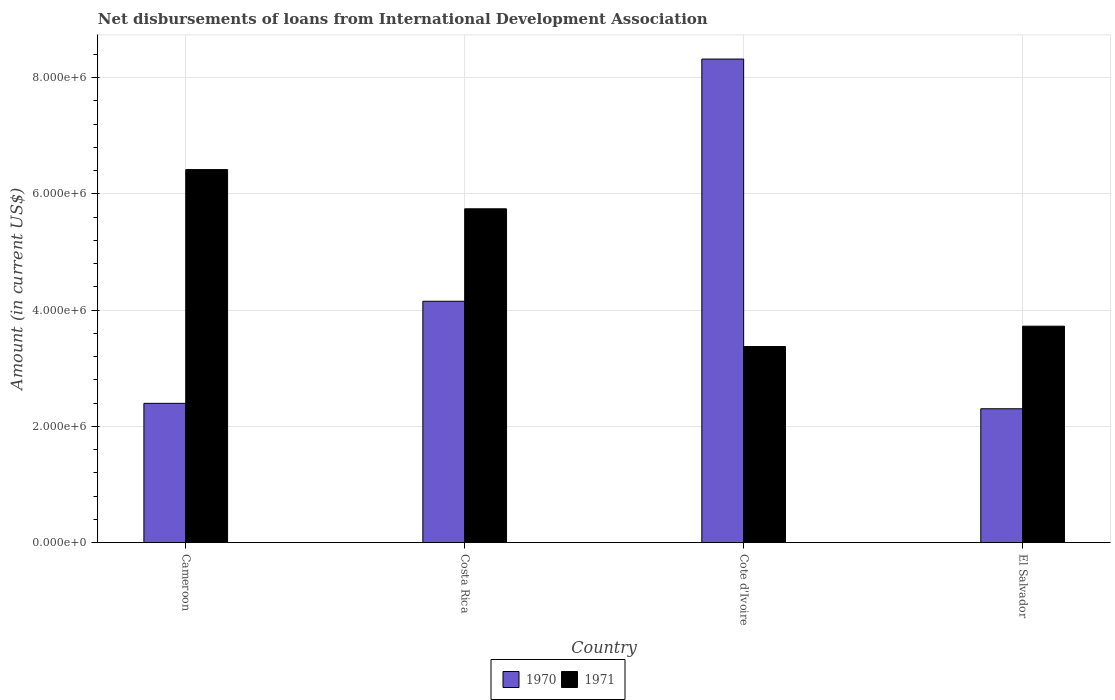How many different coloured bars are there?
Give a very brief answer. 2. How many groups of bars are there?
Keep it short and to the point. 4. How many bars are there on the 3rd tick from the left?
Offer a terse response. 2. What is the label of the 3rd group of bars from the left?
Make the answer very short. Cote d'Ivoire. In how many cases, is the number of bars for a given country not equal to the number of legend labels?
Give a very brief answer. 0. What is the amount of loans disbursed in 1970 in El Salvador?
Offer a very short reply. 2.30e+06. Across all countries, what is the maximum amount of loans disbursed in 1970?
Offer a terse response. 8.32e+06. Across all countries, what is the minimum amount of loans disbursed in 1970?
Ensure brevity in your answer.  2.30e+06. In which country was the amount of loans disbursed in 1971 maximum?
Provide a short and direct response. Cameroon. In which country was the amount of loans disbursed in 1970 minimum?
Ensure brevity in your answer.  El Salvador. What is the total amount of loans disbursed in 1971 in the graph?
Keep it short and to the point. 1.93e+07. What is the difference between the amount of loans disbursed in 1971 in Cameroon and that in Costa Rica?
Ensure brevity in your answer.  6.75e+05. What is the difference between the amount of loans disbursed in 1970 in El Salvador and the amount of loans disbursed in 1971 in Cote d'Ivoire?
Make the answer very short. -1.07e+06. What is the average amount of loans disbursed in 1971 per country?
Ensure brevity in your answer.  4.82e+06. What is the difference between the amount of loans disbursed of/in 1971 and amount of loans disbursed of/in 1970 in Cameroon?
Your answer should be very brief. 4.02e+06. In how many countries, is the amount of loans disbursed in 1971 greater than 1200000 US$?
Give a very brief answer. 4. What is the ratio of the amount of loans disbursed in 1970 in Cameroon to that in Cote d'Ivoire?
Offer a very short reply. 0.29. Is the amount of loans disbursed in 1970 in Costa Rica less than that in Cote d'Ivoire?
Offer a very short reply. Yes. What is the difference between the highest and the second highest amount of loans disbursed in 1971?
Make the answer very short. 2.70e+06. What is the difference between the highest and the lowest amount of loans disbursed in 1971?
Provide a short and direct response. 3.04e+06. What does the 1st bar from the left in El Salvador represents?
Offer a very short reply. 1970. What does the 1st bar from the right in El Salvador represents?
Provide a succinct answer. 1971. How many bars are there?
Offer a terse response. 8. Are all the bars in the graph horizontal?
Ensure brevity in your answer.  No. How many countries are there in the graph?
Your answer should be compact. 4. Are the values on the major ticks of Y-axis written in scientific E-notation?
Provide a succinct answer. Yes. Does the graph contain any zero values?
Your response must be concise. No. Does the graph contain grids?
Your response must be concise. Yes. Where does the legend appear in the graph?
Provide a succinct answer. Bottom center. What is the title of the graph?
Give a very brief answer. Net disbursements of loans from International Development Association. What is the label or title of the X-axis?
Your answer should be compact. Country. What is the label or title of the Y-axis?
Your response must be concise. Amount (in current US$). What is the Amount (in current US$) in 1970 in Cameroon?
Offer a terse response. 2.40e+06. What is the Amount (in current US$) of 1971 in Cameroon?
Offer a terse response. 6.42e+06. What is the Amount (in current US$) of 1970 in Costa Rica?
Make the answer very short. 4.15e+06. What is the Amount (in current US$) of 1971 in Costa Rica?
Your response must be concise. 5.74e+06. What is the Amount (in current US$) in 1970 in Cote d'Ivoire?
Make the answer very short. 8.32e+06. What is the Amount (in current US$) in 1971 in Cote d'Ivoire?
Your answer should be very brief. 3.37e+06. What is the Amount (in current US$) of 1970 in El Salvador?
Keep it short and to the point. 2.30e+06. What is the Amount (in current US$) in 1971 in El Salvador?
Provide a short and direct response. 3.72e+06. Across all countries, what is the maximum Amount (in current US$) of 1970?
Ensure brevity in your answer.  8.32e+06. Across all countries, what is the maximum Amount (in current US$) in 1971?
Offer a terse response. 6.42e+06. Across all countries, what is the minimum Amount (in current US$) in 1970?
Your answer should be compact. 2.30e+06. Across all countries, what is the minimum Amount (in current US$) of 1971?
Offer a terse response. 3.37e+06. What is the total Amount (in current US$) of 1970 in the graph?
Offer a terse response. 1.72e+07. What is the total Amount (in current US$) in 1971 in the graph?
Your response must be concise. 1.93e+07. What is the difference between the Amount (in current US$) of 1970 in Cameroon and that in Costa Rica?
Offer a very short reply. -1.76e+06. What is the difference between the Amount (in current US$) of 1971 in Cameroon and that in Costa Rica?
Make the answer very short. 6.75e+05. What is the difference between the Amount (in current US$) of 1970 in Cameroon and that in Cote d'Ivoire?
Give a very brief answer. -5.92e+06. What is the difference between the Amount (in current US$) of 1971 in Cameroon and that in Cote d'Ivoire?
Give a very brief answer. 3.04e+06. What is the difference between the Amount (in current US$) in 1970 in Cameroon and that in El Salvador?
Make the answer very short. 9.30e+04. What is the difference between the Amount (in current US$) of 1971 in Cameroon and that in El Salvador?
Ensure brevity in your answer.  2.70e+06. What is the difference between the Amount (in current US$) in 1970 in Costa Rica and that in Cote d'Ivoire?
Your answer should be very brief. -4.17e+06. What is the difference between the Amount (in current US$) of 1971 in Costa Rica and that in Cote d'Ivoire?
Provide a succinct answer. 2.37e+06. What is the difference between the Amount (in current US$) of 1970 in Costa Rica and that in El Salvador?
Give a very brief answer. 1.85e+06. What is the difference between the Amount (in current US$) of 1971 in Costa Rica and that in El Salvador?
Provide a succinct answer. 2.02e+06. What is the difference between the Amount (in current US$) in 1970 in Cote d'Ivoire and that in El Salvador?
Make the answer very short. 6.02e+06. What is the difference between the Amount (in current US$) of 1971 in Cote d'Ivoire and that in El Salvador?
Make the answer very short. -3.50e+05. What is the difference between the Amount (in current US$) in 1970 in Cameroon and the Amount (in current US$) in 1971 in Costa Rica?
Give a very brief answer. -3.35e+06. What is the difference between the Amount (in current US$) in 1970 in Cameroon and the Amount (in current US$) in 1971 in Cote d'Ivoire?
Give a very brief answer. -9.78e+05. What is the difference between the Amount (in current US$) of 1970 in Cameroon and the Amount (in current US$) of 1971 in El Salvador?
Provide a short and direct response. -1.33e+06. What is the difference between the Amount (in current US$) of 1970 in Costa Rica and the Amount (in current US$) of 1971 in Cote d'Ivoire?
Your answer should be compact. 7.79e+05. What is the difference between the Amount (in current US$) in 1970 in Costa Rica and the Amount (in current US$) in 1971 in El Salvador?
Give a very brief answer. 4.29e+05. What is the difference between the Amount (in current US$) of 1970 in Cote d'Ivoire and the Amount (in current US$) of 1971 in El Salvador?
Your answer should be very brief. 4.60e+06. What is the average Amount (in current US$) in 1970 per country?
Provide a short and direct response. 4.29e+06. What is the average Amount (in current US$) in 1971 per country?
Provide a short and direct response. 4.82e+06. What is the difference between the Amount (in current US$) of 1970 and Amount (in current US$) of 1971 in Cameroon?
Offer a very short reply. -4.02e+06. What is the difference between the Amount (in current US$) of 1970 and Amount (in current US$) of 1971 in Costa Rica?
Keep it short and to the point. -1.59e+06. What is the difference between the Amount (in current US$) in 1970 and Amount (in current US$) in 1971 in Cote d'Ivoire?
Your response must be concise. 4.95e+06. What is the difference between the Amount (in current US$) of 1970 and Amount (in current US$) of 1971 in El Salvador?
Offer a terse response. -1.42e+06. What is the ratio of the Amount (in current US$) of 1970 in Cameroon to that in Costa Rica?
Make the answer very short. 0.58. What is the ratio of the Amount (in current US$) in 1971 in Cameroon to that in Costa Rica?
Make the answer very short. 1.12. What is the ratio of the Amount (in current US$) in 1970 in Cameroon to that in Cote d'Ivoire?
Give a very brief answer. 0.29. What is the ratio of the Amount (in current US$) in 1971 in Cameroon to that in Cote d'Ivoire?
Provide a short and direct response. 1.9. What is the ratio of the Amount (in current US$) in 1970 in Cameroon to that in El Salvador?
Provide a short and direct response. 1.04. What is the ratio of the Amount (in current US$) in 1971 in Cameroon to that in El Salvador?
Make the answer very short. 1.72. What is the ratio of the Amount (in current US$) of 1970 in Costa Rica to that in Cote d'Ivoire?
Make the answer very short. 0.5. What is the ratio of the Amount (in current US$) in 1971 in Costa Rica to that in Cote d'Ivoire?
Keep it short and to the point. 1.7. What is the ratio of the Amount (in current US$) in 1970 in Costa Rica to that in El Salvador?
Make the answer very short. 1.8. What is the ratio of the Amount (in current US$) in 1971 in Costa Rica to that in El Salvador?
Your answer should be very brief. 1.54. What is the ratio of the Amount (in current US$) of 1970 in Cote d'Ivoire to that in El Salvador?
Offer a very short reply. 3.61. What is the ratio of the Amount (in current US$) of 1971 in Cote d'Ivoire to that in El Salvador?
Offer a terse response. 0.91. What is the difference between the highest and the second highest Amount (in current US$) of 1970?
Your answer should be compact. 4.17e+06. What is the difference between the highest and the second highest Amount (in current US$) of 1971?
Your answer should be compact. 6.75e+05. What is the difference between the highest and the lowest Amount (in current US$) in 1970?
Offer a very short reply. 6.02e+06. What is the difference between the highest and the lowest Amount (in current US$) of 1971?
Offer a very short reply. 3.04e+06. 